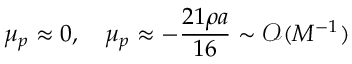Convert formula to latex. <formula><loc_0><loc_0><loc_500><loc_500>\mu _ { p } \approx 0 , \quad \mu _ { p } \approx - \frac { 2 1 \rho a } { 1 6 } \sim \mathcal { O } ( M ^ { - 1 } )</formula> 